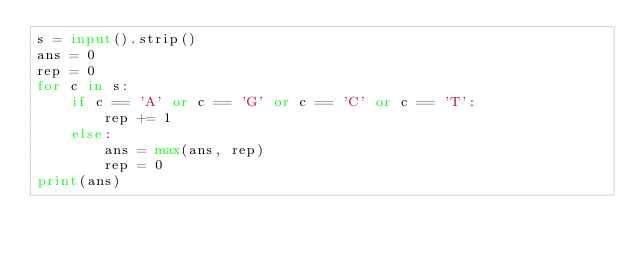<code> <loc_0><loc_0><loc_500><loc_500><_Python_>s = input().strip()
ans = 0
rep = 0
for c in s:
    if c == 'A' or c == 'G' or c == 'C' or c == 'T':
        rep += 1
    else:
        ans = max(ans, rep)
        rep = 0
print(ans)
</code> 